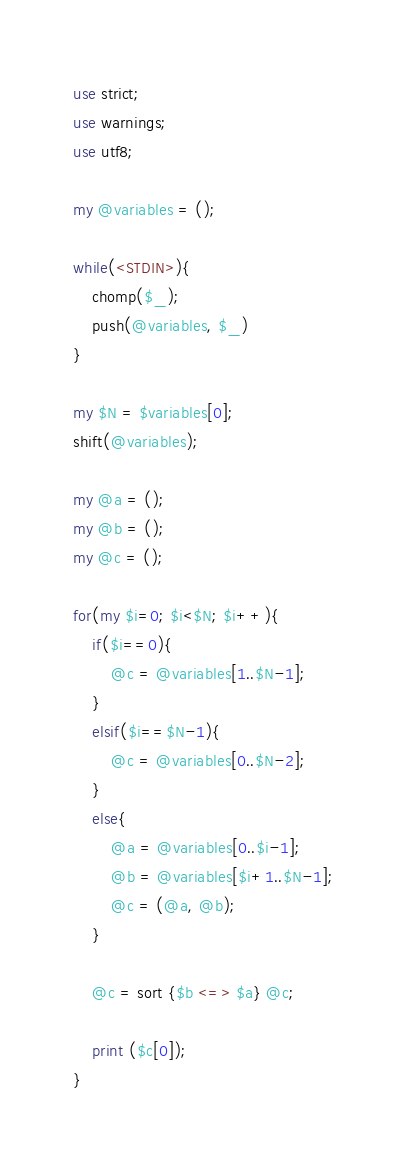<code> <loc_0><loc_0><loc_500><loc_500><_Perl_>use strict;
use warnings;
use utf8;

my @variables = ();

while(<STDIN>){
    chomp($_);
    push(@variables, $_)
}

my $N = $variables[0];
shift(@variables);

my @a = ();
my @b = ();
my @c = ();

for(my $i=0; $i<$N; $i++){
    if($i==0){
        @c = @variables[1..$N-1];
    }
    elsif($i==$N-1){
        @c = @variables[0..$N-2];
    }
    else{
        @a = @variables[0..$i-1];
        @b = @variables[$i+1..$N-1];
        @c = (@a, @b);
    }

    @c = sort {$b <=> $a} @c;

    print ($c[0]);
}
</code> 